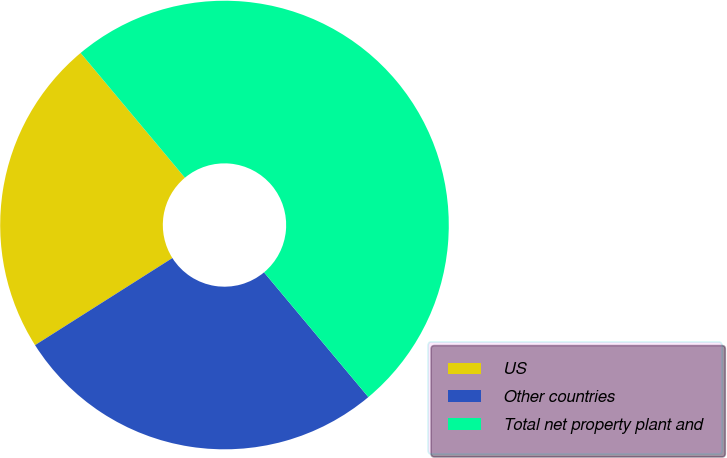Convert chart. <chart><loc_0><loc_0><loc_500><loc_500><pie_chart><fcel>US<fcel>Other countries<fcel>Total net property plant and<nl><fcel>22.91%<fcel>27.09%<fcel>50.0%<nl></chart> 